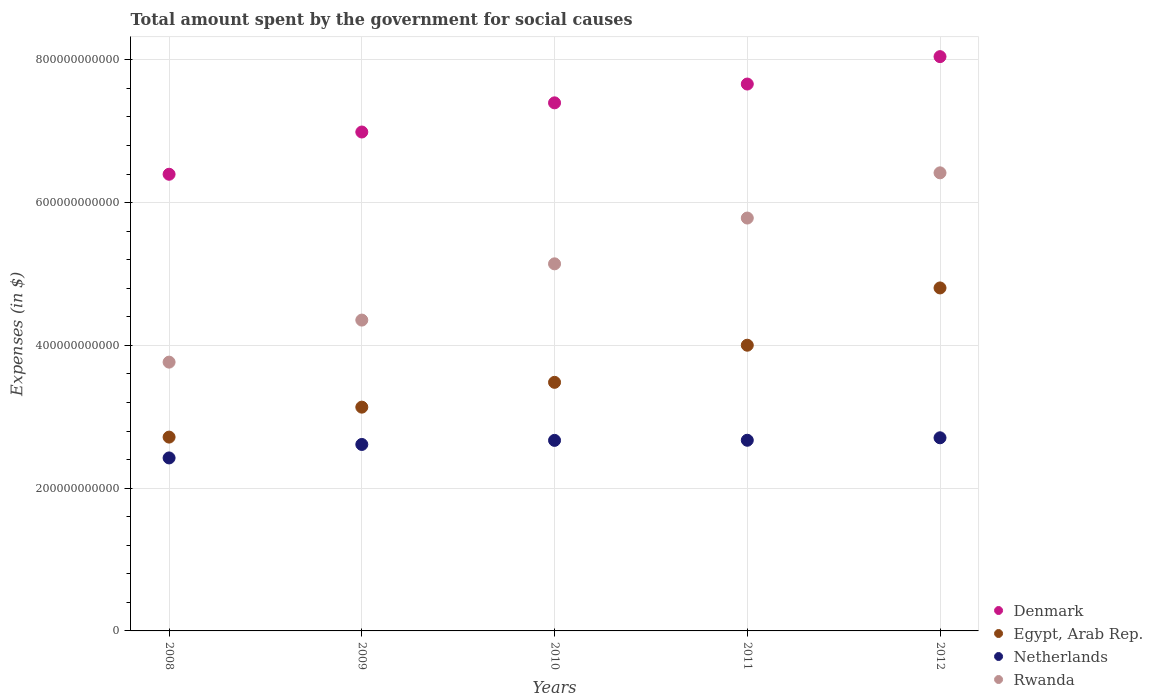Is the number of dotlines equal to the number of legend labels?
Keep it short and to the point. Yes. What is the amount spent for social causes by the government in Netherlands in 2011?
Make the answer very short. 2.67e+11. Across all years, what is the maximum amount spent for social causes by the government in Denmark?
Keep it short and to the point. 8.04e+11. Across all years, what is the minimum amount spent for social causes by the government in Egypt, Arab Rep.?
Provide a short and direct response. 2.71e+11. In which year was the amount spent for social causes by the government in Netherlands maximum?
Offer a terse response. 2012. In which year was the amount spent for social causes by the government in Egypt, Arab Rep. minimum?
Provide a succinct answer. 2008. What is the total amount spent for social causes by the government in Egypt, Arab Rep. in the graph?
Ensure brevity in your answer.  1.81e+12. What is the difference between the amount spent for social causes by the government in Netherlands in 2009 and that in 2011?
Give a very brief answer. -5.88e+09. What is the difference between the amount spent for social causes by the government in Egypt, Arab Rep. in 2008 and the amount spent for social causes by the government in Denmark in 2012?
Give a very brief answer. -5.33e+11. What is the average amount spent for social causes by the government in Egypt, Arab Rep. per year?
Ensure brevity in your answer.  3.63e+11. In the year 2011, what is the difference between the amount spent for social causes by the government in Egypt, Arab Rep. and amount spent for social causes by the government in Denmark?
Keep it short and to the point. -3.66e+11. In how many years, is the amount spent for social causes by the government in Egypt, Arab Rep. greater than 360000000000 $?
Your answer should be very brief. 2. What is the ratio of the amount spent for social causes by the government in Rwanda in 2008 to that in 2012?
Ensure brevity in your answer.  0.59. Is the amount spent for social causes by the government in Rwanda in 2008 less than that in 2010?
Give a very brief answer. Yes. What is the difference between the highest and the second highest amount spent for social causes by the government in Denmark?
Offer a terse response. 3.84e+1. What is the difference between the highest and the lowest amount spent for social causes by the government in Netherlands?
Ensure brevity in your answer.  2.82e+1. In how many years, is the amount spent for social causes by the government in Denmark greater than the average amount spent for social causes by the government in Denmark taken over all years?
Your answer should be compact. 3. Is the sum of the amount spent for social causes by the government in Denmark in 2011 and 2012 greater than the maximum amount spent for social causes by the government in Rwanda across all years?
Make the answer very short. Yes. Does the amount spent for social causes by the government in Netherlands monotonically increase over the years?
Give a very brief answer. Yes. Is the amount spent for social causes by the government in Rwanda strictly greater than the amount spent for social causes by the government in Egypt, Arab Rep. over the years?
Your response must be concise. Yes. How many dotlines are there?
Make the answer very short. 4. How many years are there in the graph?
Your answer should be compact. 5. What is the difference between two consecutive major ticks on the Y-axis?
Your answer should be compact. 2.00e+11. Does the graph contain any zero values?
Provide a succinct answer. No. Does the graph contain grids?
Offer a very short reply. Yes. What is the title of the graph?
Offer a terse response. Total amount spent by the government for social causes. Does "Madagascar" appear as one of the legend labels in the graph?
Give a very brief answer. No. What is the label or title of the Y-axis?
Make the answer very short. Expenses (in $). What is the Expenses (in $) of Denmark in 2008?
Keep it short and to the point. 6.40e+11. What is the Expenses (in $) of Egypt, Arab Rep. in 2008?
Provide a succinct answer. 2.71e+11. What is the Expenses (in $) of Netherlands in 2008?
Make the answer very short. 2.42e+11. What is the Expenses (in $) in Rwanda in 2008?
Your answer should be very brief. 3.77e+11. What is the Expenses (in $) in Denmark in 2009?
Your answer should be compact. 6.99e+11. What is the Expenses (in $) in Egypt, Arab Rep. in 2009?
Offer a terse response. 3.13e+11. What is the Expenses (in $) in Netherlands in 2009?
Keep it short and to the point. 2.61e+11. What is the Expenses (in $) in Rwanda in 2009?
Provide a short and direct response. 4.35e+11. What is the Expenses (in $) of Denmark in 2010?
Make the answer very short. 7.40e+11. What is the Expenses (in $) of Egypt, Arab Rep. in 2010?
Give a very brief answer. 3.48e+11. What is the Expenses (in $) in Netherlands in 2010?
Your response must be concise. 2.67e+11. What is the Expenses (in $) in Rwanda in 2010?
Your response must be concise. 5.14e+11. What is the Expenses (in $) in Denmark in 2011?
Offer a very short reply. 7.66e+11. What is the Expenses (in $) in Egypt, Arab Rep. in 2011?
Your answer should be very brief. 4.00e+11. What is the Expenses (in $) of Netherlands in 2011?
Offer a terse response. 2.67e+11. What is the Expenses (in $) of Rwanda in 2011?
Ensure brevity in your answer.  5.78e+11. What is the Expenses (in $) of Denmark in 2012?
Your answer should be compact. 8.04e+11. What is the Expenses (in $) in Egypt, Arab Rep. in 2012?
Offer a terse response. 4.80e+11. What is the Expenses (in $) of Netherlands in 2012?
Make the answer very short. 2.71e+11. What is the Expenses (in $) in Rwanda in 2012?
Keep it short and to the point. 6.42e+11. Across all years, what is the maximum Expenses (in $) of Denmark?
Your response must be concise. 8.04e+11. Across all years, what is the maximum Expenses (in $) of Egypt, Arab Rep.?
Offer a very short reply. 4.80e+11. Across all years, what is the maximum Expenses (in $) of Netherlands?
Your response must be concise. 2.71e+11. Across all years, what is the maximum Expenses (in $) in Rwanda?
Your response must be concise. 6.42e+11. Across all years, what is the minimum Expenses (in $) in Denmark?
Provide a succinct answer. 6.40e+11. Across all years, what is the minimum Expenses (in $) of Egypt, Arab Rep.?
Your answer should be very brief. 2.71e+11. Across all years, what is the minimum Expenses (in $) of Netherlands?
Your response must be concise. 2.42e+11. Across all years, what is the minimum Expenses (in $) of Rwanda?
Offer a very short reply. 3.77e+11. What is the total Expenses (in $) in Denmark in the graph?
Keep it short and to the point. 3.65e+12. What is the total Expenses (in $) in Egypt, Arab Rep. in the graph?
Your response must be concise. 1.81e+12. What is the total Expenses (in $) of Netherlands in the graph?
Offer a very short reply. 1.31e+12. What is the total Expenses (in $) of Rwanda in the graph?
Give a very brief answer. 2.55e+12. What is the difference between the Expenses (in $) of Denmark in 2008 and that in 2009?
Keep it short and to the point. -5.92e+1. What is the difference between the Expenses (in $) of Egypt, Arab Rep. in 2008 and that in 2009?
Give a very brief answer. -4.20e+1. What is the difference between the Expenses (in $) in Netherlands in 2008 and that in 2009?
Ensure brevity in your answer.  -1.89e+1. What is the difference between the Expenses (in $) in Rwanda in 2008 and that in 2009?
Offer a terse response. -5.89e+1. What is the difference between the Expenses (in $) of Denmark in 2008 and that in 2010?
Provide a succinct answer. -1.00e+11. What is the difference between the Expenses (in $) in Egypt, Arab Rep. in 2008 and that in 2010?
Provide a succinct answer. -7.67e+1. What is the difference between the Expenses (in $) of Netherlands in 2008 and that in 2010?
Offer a terse response. -2.46e+1. What is the difference between the Expenses (in $) of Rwanda in 2008 and that in 2010?
Provide a succinct answer. -1.38e+11. What is the difference between the Expenses (in $) in Denmark in 2008 and that in 2011?
Provide a succinct answer. -1.26e+11. What is the difference between the Expenses (in $) in Egypt, Arab Rep. in 2008 and that in 2011?
Provide a succinct answer. -1.29e+11. What is the difference between the Expenses (in $) in Netherlands in 2008 and that in 2011?
Provide a short and direct response. -2.48e+1. What is the difference between the Expenses (in $) of Rwanda in 2008 and that in 2011?
Your answer should be very brief. -2.02e+11. What is the difference between the Expenses (in $) in Denmark in 2008 and that in 2012?
Ensure brevity in your answer.  -1.65e+11. What is the difference between the Expenses (in $) of Egypt, Arab Rep. in 2008 and that in 2012?
Keep it short and to the point. -2.09e+11. What is the difference between the Expenses (in $) in Netherlands in 2008 and that in 2012?
Ensure brevity in your answer.  -2.82e+1. What is the difference between the Expenses (in $) of Rwanda in 2008 and that in 2012?
Offer a very short reply. -2.65e+11. What is the difference between the Expenses (in $) of Denmark in 2009 and that in 2010?
Offer a very short reply. -4.09e+1. What is the difference between the Expenses (in $) of Egypt, Arab Rep. in 2009 and that in 2010?
Offer a terse response. -3.48e+1. What is the difference between the Expenses (in $) of Netherlands in 2009 and that in 2010?
Make the answer very short. -5.71e+09. What is the difference between the Expenses (in $) of Rwanda in 2009 and that in 2010?
Your answer should be very brief. -7.88e+1. What is the difference between the Expenses (in $) of Denmark in 2009 and that in 2011?
Make the answer very short. -6.72e+1. What is the difference between the Expenses (in $) in Egypt, Arab Rep. in 2009 and that in 2011?
Your response must be concise. -8.68e+1. What is the difference between the Expenses (in $) in Netherlands in 2009 and that in 2011?
Offer a very short reply. -5.88e+09. What is the difference between the Expenses (in $) of Rwanda in 2009 and that in 2011?
Your answer should be compact. -1.43e+11. What is the difference between the Expenses (in $) in Denmark in 2009 and that in 2012?
Make the answer very short. -1.06e+11. What is the difference between the Expenses (in $) of Egypt, Arab Rep. in 2009 and that in 2012?
Offer a terse response. -1.67e+11. What is the difference between the Expenses (in $) in Netherlands in 2009 and that in 2012?
Offer a very short reply. -9.34e+09. What is the difference between the Expenses (in $) of Rwanda in 2009 and that in 2012?
Offer a terse response. -2.06e+11. What is the difference between the Expenses (in $) of Denmark in 2010 and that in 2011?
Offer a very short reply. -2.63e+1. What is the difference between the Expenses (in $) in Egypt, Arab Rep. in 2010 and that in 2011?
Offer a very short reply. -5.20e+1. What is the difference between the Expenses (in $) in Netherlands in 2010 and that in 2011?
Your answer should be very brief. -1.72e+08. What is the difference between the Expenses (in $) in Rwanda in 2010 and that in 2011?
Your answer should be compact. -6.41e+1. What is the difference between the Expenses (in $) of Denmark in 2010 and that in 2012?
Your answer should be very brief. -6.47e+1. What is the difference between the Expenses (in $) in Egypt, Arab Rep. in 2010 and that in 2012?
Give a very brief answer. -1.32e+11. What is the difference between the Expenses (in $) of Netherlands in 2010 and that in 2012?
Provide a succinct answer. -3.62e+09. What is the difference between the Expenses (in $) in Rwanda in 2010 and that in 2012?
Offer a very short reply. -1.27e+11. What is the difference between the Expenses (in $) in Denmark in 2011 and that in 2012?
Make the answer very short. -3.84e+1. What is the difference between the Expenses (in $) in Egypt, Arab Rep. in 2011 and that in 2012?
Offer a terse response. -8.02e+1. What is the difference between the Expenses (in $) in Netherlands in 2011 and that in 2012?
Provide a short and direct response. -3.45e+09. What is the difference between the Expenses (in $) in Rwanda in 2011 and that in 2012?
Your response must be concise. -6.33e+1. What is the difference between the Expenses (in $) in Denmark in 2008 and the Expenses (in $) in Egypt, Arab Rep. in 2009?
Offer a very short reply. 3.26e+11. What is the difference between the Expenses (in $) of Denmark in 2008 and the Expenses (in $) of Netherlands in 2009?
Offer a terse response. 3.78e+11. What is the difference between the Expenses (in $) in Denmark in 2008 and the Expenses (in $) in Rwanda in 2009?
Your answer should be compact. 2.04e+11. What is the difference between the Expenses (in $) of Egypt, Arab Rep. in 2008 and the Expenses (in $) of Netherlands in 2009?
Make the answer very short. 1.03e+1. What is the difference between the Expenses (in $) of Egypt, Arab Rep. in 2008 and the Expenses (in $) of Rwanda in 2009?
Keep it short and to the point. -1.64e+11. What is the difference between the Expenses (in $) in Netherlands in 2008 and the Expenses (in $) in Rwanda in 2009?
Your answer should be compact. -1.93e+11. What is the difference between the Expenses (in $) in Denmark in 2008 and the Expenses (in $) in Egypt, Arab Rep. in 2010?
Offer a terse response. 2.91e+11. What is the difference between the Expenses (in $) of Denmark in 2008 and the Expenses (in $) of Netherlands in 2010?
Offer a very short reply. 3.73e+11. What is the difference between the Expenses (in $) in Denmark in 2008 and the Expenses (in $) in Rwanda in 2010?
Keep it short and to the point. 1.25e+11. What is the difference between the Expenses (in $) in Egypt, Arab Rep. in 2008 and the Expenses (in $) in Netherlands in 2010?
Make the answer very short. 4.58e+09. What is the difference between the Expenses (in $) of Egypt, Arab Rep. in 2008 and the Expenses (in $) of Rwanda in 2010?
Provide a succinct answer. -2.43e+11. What is the difference between the Expenses (in $) in Netherlands in 2008 and the Expenses (in $) in Rwanda in 2010?
Give a very brief answer. -2.72e+11. What is the difference between the Expenses (in $) of Denmark in 2008 and the Expenses (in $) of Egypt, Arab Rep. in 2011?
Give a very brief answer. 2.39e+11. What is the difference between the Expenses (in $) in Denmark in 2008 and the Expenses (in $) in Netherlands in 2011?
Offer a very short reply. 3.73e+11. What is the difference between the Expenses (in $) of Denmark in 2008 and the Expenses (in $) of Rwanda in 2011?
Your response must be concise. 6.13e+1. What is the difference between the Expenses (in $) of Egypt, Arab Rep. in 2008 and the Expenses (in $) of Netherlands in 2011?
Give a very brief answer. 4.41e+09. What is the difference between the Expenses (in $) of Egypt, Arab Rep. in 2008 and the Expenses (in $) of Rwanda in 2011?
Give a very brief answer. -3.07e+11. What is the difference between the Expenses (in $) in Netherlands in 2008 and the Expenses (in $) in Rwanda in 2011?
Give a very brief answer. -3.36e+11. What is the difference between the Expenses (in $) in Denmark in 2008 and the Expenses (in $) in Egypt, Arab Rep. in 2012?
Provide a short and direct response. 1.59e+11. What is the difference between the Expenses (in $) in Denmark in 2008 and the Expenses (in $) in Netherlands in 2012?
Your response must be concise. 3.69e+11. What is the difference between the Expenses (in $) in Denmark in 2008 and the Expenses (in $) in Rwanda in 2012?
Your answer should be compact. -2.00e+09. What is the difference between the Expenses (in $) in Egypt, Arab Rep. in 2008 and the Expenses (in $) in Netherlands in 2012?
Ensure brevity in your answer.  9.57e+08. What is the difference between the Expenses (in $) in Egypt, Arab Rep. in 2008 and the Expenses (in $) in Rwanda in 2012?
Your answer should be very brief. -3.70e+11. What is the difference between the Expenses (in $) of Netherlands in 2008 and the Expenses (in $) of Rwanda in 2012?
Give a very brief answer. -3.99e+11. What is the difference between the Expenses (in $) in Denmark in 2009 and the Expenses (in $) in Egypt, Arab Rep. in 2010?
Give a very brief answer. 3.51e+11. What is the difference between the Expenses (in $) in Denmark in 2009 and the Expenses (in $) in Netherlands in 2010?
Offer a terse response. 4.32e+11. What is the difference between the Expenses (in $) of Denmark in 2009 and the Expenses (in $) of Rwanda in 2010?
Give a very brief answer. 1.85e+11. What is the difference between the Expenses (in $) in Egypt, Arab Rep. in 2009 and the Expenses (in $) in Netherlands in 2010?
Offer a terse response. 4.65e+1. What is the difference between the Expenses (in $) in Egypt, Arab Rep. in 2009 and the Expenses (in $) in Rwanda in 2010?
Give a very brief answer. -2.01e+11. What is the difference between the Expenses (in $) of Netherlands in 2009 and the Expenses (in $) of Rwanda in 2010?
Provide a succinct answer. -2.53e+11. What is the difference between the Expenses (in $) in Denmark in 2009 and the Expenses (in $) in Egypt, Arab Rep. in 2011?
Your response must be concise. 2.99e+11. What is the difference between the Expenses (in $) in Denmark in 2009 and the Expenses (in $) in Netherlands in 2011?
Provide a short and direct response. 4.32e+11. What is the difference between the Expenses (in $) in Denmark in 2009 and the Expenses (in $) in Rwanda in 2011?
Provide a short and direct response. 1.21e+11. What is the difference between the Expenses (in $) in Egypt, Arab Rep. in 2009 and the Expenses (in $) in Netherlands in 2011?
Give a very brief answer. 4.64e+1. What is the difference between the Expenses (in $) in Egypt, Arab Rep. in 2009 and the Expenses (in $) in Rwanda in 2011?
Your response must be concise. -2.65e+11. What is the difference between the Expenses (in $) in Netherlands in 2009 and the Expenses (in $) in Rwanda in 2011?
Offer a very short reply. -3.17e+11. What is the difference between the Expenses (in $) of Denmark in 2009 and the Expenses (in $) of Egypt, Arab Rep. in 2012?
Offer a terse response. 2.18e+11. What is the difference between the Expenses (in $) in Denmark in 2009 and the Expenses (in $) in Netherlands in 2012?
Keep it short and to the point. 4.28e+11. What is the difference between the Expenses (in $) in Denmark in 2009 and the Expenses (in $) in Rwanda in 2012?
Ensure brevity in your answer.  5.72e+1. What is the difference between the Expenses (in $) of Egypt, Arab Rep. in 2009 and the Expenses (in $) of Netherlands in 2012?
Your answer should be very brief. 4.29e+1. What is the difference between the Expenses (in $) in Egypt, Arab Rep. in 2009 and the Expenses (in $) in Rwanda in 2012?
Offer a terse response. -3.28e+11. What is the difference between the Expenses (in $) of Netherlands in 2009 and the Expenses (in $) of Rwanda in 2012?
Provide a short and direct response. -3.80e+11. What is the difference between the Expenses (in $) in Denmark in 2010 and the Expenses (in $) in Egypt, Arab Rep. in 2011?
Give a very brief answer. 3.40e+11. What is the difference between the Expenses (in $) in Denmark in 2010 and the Expenses (in $) in Netherlands in 2011?
Provide a short and direct response. 4.73e+11. What is the difference between the Expenses (in $) in Denmark in 2010 and the Expenses (in $) in Rwanda in 2011?
Offer a terse response. 1.61e+11. What is the difference between the Expenses (in $) of Egypt, Arab Rep. in 2010 and the Expenses (in $) of Netherlands in 2011?
Your answer should be compact. 8.11e+1. What is the difference between the Expenses (in $) of Egypt, Arab Rep. in 2010 and the Expenses (in $) of Rwanda in 2011?
Offer a terse response. -2.30e+11. What is the difference between the Expenses (in $) in Netherlands in 2010 and the Expenses (in $) in Rwanda in 2011?
Your response must be concise. -3.11e+11. What is the difference between the Expenses (in $) of Denmark in 2010 and the Expenses (in $) of Egypt, Arab Rep. in 2012?
Provide a short and direct response. 2.59e+11. What is the difference between the Expenses (in $) in Denmark in 2010 and the Expenses (in $) in Netherlands in 2012?
Give a very brief answer. 4.69e+11. What is the difference between the Expenses (in $) in Denmark in 2010 and the Expenses (in $) in Rwanda in 2012?
Your answer should be very brief. 9.80e+1. What is the difference between the Expenses (in $) of Egypt, Arab Rep. in 2010 and the Expenses (in $) of Netherlands in 2012?
Offer a very short reply. 7.77e+1. What is the difference between the Expenses (in $) in Egypt, Arab Rep. in 2010 and the Expenses (in $) in Rwanda in 2012?
Your answer should be compact. -2.93e+11. What is the difference between the Expenses (in $) of Netherlands in 2010 and the Expenses (in $) of Rwanda in 2012?
Your answer should be very brief. -3.75e+11. What is the difference between the Expenses (in $) in Denmark in 2011 and the Expenses (in $) in Egypt, Arab Rep. in 2012?
Your response must be concise. 2.86e+11. What is the difference between the Expenses (in $) in Denmark in 2011 and the Expenses (in $) in Netherlands in 2012?
Make the answer very short. 4.96e+11. What is the difference between the Expenses (in $) of Denmark in 2011 and the Expenses (in $) of Rwanda in 2012?
Offer a very short reply. 1.24e+11. What is the difference between the Expenses (in $) in Egypt, Arab Rep. in 2011 and the Expenses (in $) in Netherlands in 2012?
Offer a terse response. 1.30e+11. What is the difference between the Expenses (in $) in Egypt, Arab Rep. in 2011 and the Expenses (in $) in Rwanda in 2012?
Your answer should be compact. -2.41e+11. What is the difference between the Expenses (in $) in Netherlands in 2011 and the Expenses (in $) in Rwanda in 2012?
Ensure brevity in your answer.  -3.75e+11. What is the average Expenses (in $) in Denmark per year?
Offer a very short reply. 7.30e+11. What is the average Expenses (in $) of Egypt, Arab Rep. per year?
Give a very brief answer. 3.63e+11. What is the average Expenses (in $) of Netherlands per year?
Your answer should be compact. 2.62e+11. What is the average Expenses (in $) of Rwanda per year?
Your answer should be very brief. 5.09e+11. In the year 2008, what is the difference between the Expenses (in $) in Denmark and Expenses (in $) in Egypt, Arab Rep.?
Ensure brevity in your answer.  3.68e+11. In the year 2008, what is the difference between the Expenses (in $) of Denmark and Expenses (in $) of Netherlands?
Offer a very short reply. 3.97e+11. In the year 2008, what is the difference between the Expenses (in $) in Denmark and Expenses (in $) in Rwanda?
Provide a succinct answer. 2.63e+11. In the year 2008, what is the difference between the Expenses (in $) in Egypt, Arab Rep. and Expenses (in $) in Netherlands?
Give a very brief answer. 2.92e+1. In the year 2008, what is the difference between the Expenses (in $) in Egypt, Arab Rep. and Expenses (in $) in Rwanda?
Your answer should be compact. -1.05e+11. In the year 2008, what is the difference between the Expenses (in $) in Netherlands and Expenses (in $) in Rwanda?
Your answer should be compact. -1.34e+11. In the year 2009, what is the difference between the Expenses (in $) in Denmark and Expenses (in $) in Egypt, Arab Rep.?
Provide a short and direct response. 3.85e+11. In the year 2009, what is the difference between the Expenses (in $) of Denmark and Expenses (in $) of Netherlands?
Offer a very short reply. 4.38e+11. In the year 2009, what is the difference between the Expenses (in $) of Denmark and Expenses (in $) of Rwanda?
Give a very brief answer. 2.63e+11. In the year 2009, what is the difference between the Expenses (in $) in Egypt, Arab Rep. and Expenses (in $) in Netherlands?
Provide a succinct answer. 5.23e+1. In the year 2009, what is the difference between the Expenses (in $) of Egypt, Arab Rep. and Expenses (in $) of Rwanda?
Provide a short and direct response. -1.22e+11. In the year 2009, what is the difference between the Expenses (in $) of Netherlands and Expenses (in $) of Rwanda?
Ensure brevity in your answer.  -1.74e+11. In the year 2010, what is the difference between the Expenses (in $) in Denmark and Expenses (in $) in Egypt, Arab Rep.?
Your answer should be compact. 3.92e+11. In the year 2010, what is the difference between the Expenses (in $) in Denmark and Expenses (in $) in Netherlands?
Give a very brief answer. 4.73e+11. In the year 2010, what is the difference between the Expenses (in $) in Denmark and Expenses (in $) in Rwanda?
Provide a succinct answer. 2.26e+11. In the year 2010, what is the difference between the Expenses (in $) in Egypt, Arab Rep. and Expenses (in $) in Netherlands?
Offer a very short reply. 8.13e+1. In the year 2010, what is the difference between the Expenses (in $) of Egypt, Arab Rep. and Expenses (in $) of Rwanda?
Provide a short and direct response. -1.66e+11. In the year 2010, what is the difference between the Expenses (in $) in Netherlands and Expenses (in $) in Rwanda?
Make the answer very short. -2.47e+11. In the year 2011, what is the difference between the Expenses (in $) in Denmark and Expenses (in $) in Egypt, Arab Rep.?
Ensure brevity in your answer.  3.66e+11. In the year 2011, what is the difference between the Expenses (in $) of Denmark and Expenses (in $) of Netherlands?
Give a very brief answer. 4.99e+11. In the year 2011, what is the difference between the Expenses (in $) in Denmark and Expenses (in $) in Rwanda?
Your answer should be very brief. 1.88e+11. In the year 2011, what is the difference between the Expenses (in $) in Egypt, Arab Rep. and Expenses (in $) in Netherlands?
Keep it short and to the point. 1.33e+11. In the year 2011, what is the difference between the Expenses (in $) of Egypt, Arab Rep. and Expenses (in $) of Rwanda?
Provide a succinct answer. -1.78e+11. In the year 2011, what is the difference between the Expenses (in $) in Netherlands and Expenses (in $) in Rwanda?
Make the answer very short. -3.11e+11. In the year 2012, what is the difference between the Expenses (in $) of Denmark and Expenses (in $) of Egypt, Arab Rep.?
Provide a short and direct response. 3.24e+11. In the year 2012, what is the difference between the Expenses (in $) of Denmark and Expenses (in $) of Netherlands?
Ensure brevity in your answer.  5.34e+11. In the year 2012, what is the difference between the Expenses (in $) of Denmark and Expenses (in $) of Rwanda?
Provide a short and direct response. 1.63e+11. In the year 2012, what is the difference between the Expenses (in $) of Egypt, Arab Rep. and Expenses (in $) of Netherlands?
Provide a succinct answer. 2.10e+11. In the year 2012, what is the difference between the Expenses (in $) of Egypt, Arab Rep. and Expenses (in $) of Rwanda?
Ensure brevity in your answer.  -1.61e+11. In the year 2012, what is the difference between the Expenses (in $) in Netherlands and Expenses (in $) in Rwanda?
Your answer should be very brief. -3.71e+11. What is the ratio of the Expenses (in $) of Denmark in 2008 to that in 2009?
Your answer should be compact. 0.92. What is the ratio of the Expenses (in $) of Egypt, Arab Rep. in 2008 to that in 2009?
Your answer should be very brief. 0.87. What is the ratio of the Expenses (in $) in Netherlands in 2008 to that in 2009?
Provide a succinct answer. 0.93. What is the ratio of the Expenses (in $) in Rwanda in 2008 to that in 2009?
Provide a short and direct response. 0.86. What is the ratio of the Expenses (in $) in Denmark in 2008 to that in 2010?
Your answer should be compact. 0.86. What is the ratio of the Expenses (in $) of Egypt, Arab Rep. in 2008 to that in 2010?
Provide a short and direct response. 0.78. What is the ratio of the Expenses (in $) of Netherlands in 2008 to that in 2010?
Keep it short and to the point. 0.91. What is the ratio of the Expenses (in $) in Rwanda in 2008 to that in 2010?
Your response must be concise. 0.73. What is the ratio of the Expenses (in $) of Denmark in 2008 to that in 2011?
Give a very brief answer. 0.83. What is the ratio of the Expenses (in $) in Egypt, Arab Rep. in 2008 to that in 2011?
Give a very brief answer. 0.68. What is the ratio of the Expenses (in $) of Netherlands in 2008 to that in 2011?
Provide a short and direct response. 0.91. What is the ratio of the Expenses (in $) of Rwanda in 2008 to that in 2011?
Ensure brevity in your answer.  0.65. What is the ratio of the Expenses (in $) of Denmark in 2008 to that in 2012?
Provide a succinct answer. 0.8. What is the ratio of the Expenses (in $) of Egypt, Arab Rep. in 2008 to that in 2012?
Ensure brevity in your answer.  0.57. What is the ratio of the Expenses (in $) of Netherlands in 2008 to that in 2012?
Your answer should be compact. 0.9. What is the ratio of the Expenses (in $) of Rwanda in 2008 to that in 2012?
Keep it short and to the point. 0.59. What is the ratio of the Expenses (in $) in Denmark in 2009 to that in 2010?
Your answer should be compact. 0.94. What is the ratio of the Expenses (in $) in Egypt, Arab Rep. in 2009 to that in 2010?
Offer a very short reply. 0.9. What is the ratio of the Expenses (in $) in Netherlands in 2009 to that in 2010?
Your answer should be compact. 0.98. What is the ratio of the Expenses (in $) in Rwanda in 2009 to that in 2010?
Your answer should be compact. 0.85. What is the ratio of the Expenses (in $) in Denmark in 2009 to that in 2011?
Give a very brief answer. 0.91. What is the ratio of the Expenses (in $) of Egypt, Arab Rep. in 2009 to that in 2011?
Offer a very short reply. 0.78. What is the ratio of the Expenses (in $) in Rwanda in 2009 to that in 2011?
Your response must be concise. 0.75. What is the ratio of the Expenses (in $) of Denmark in 2009 to that in 2012?
Offer a terse response. 0.87. What is the ratio of the Expenses (in $) of Egypt, Arab Rep. in 2009 to that in 2012?
Make the answer very short. 0.65. What is the ratio of the Expenses (in $) in Netherlands in 2009 to that in 2012?
Ensure brevity in your answer.  0.97. What is the ratio of the Expenses (in $) in Rwanda in 2009 to that in 2012?
Your response must be concise. 0.68. What is the ratio of the Expenses (in $) of Denmark in 2010 to that in 2011?
Keep it short and to the point. 0.97. What is the ratio of the Expenses (in $) in Egypt, Arab Rep. in 2010 to that in 2011?
Your answer should be compact. 0.87. What is the ratio of the Expenses (in $) of Netherlands in 2010 to that in 2011?
Make the answer very short. 1. What is the ratio of the Expenses (in $) of Rwanda in 2010 to that in 2011?
Offer a terse response. 0.89. What is the ratio of the Expenses (in $) of Denmark in 2010 to that in 2012?
Give a very brief answer. 0.92. What is the ratio of the Expenses (in $) in Egypt, Arab Rep. in 2010 to that in 2012?
Provide a short and direct response. 0.72. What is the ratio of the Expenses (in $) in Netherlands in 2010 to that in 2012?
Give a very brief answer. 0.99. What is the ratio of the Expenses (in $) of Rwanda in 2010 to that in 2012?
Give a very brief answer. 0.8. What is the ratio of the Expenses (in $) of Denmark in 2011 to that in 2012?
Ensure brevity in your answer.  0.95. What is the ratio of the Expenses (in $) of Egypt, Arab Rep. in 2011 to that in 2012?
Make the answer very short. 0.83. What is the ratio of the Expenses (in $) of Netherlands in 2011 to that in 2012?
Give a very brief answer. 0.99. What is the ratio of the Expenses (in $) of Rwanda in 2011 to that in 2012?
Offer a very short reply. 0.9. What is the difference between the highest and the second highest Expenses (in $) in Denmark?
Give a very brief answer. 3.84e+1. What is the difference between the highest and the second highest Expenses (in $) of Egypt, Arab Rep.?
Give a very brief answer. 8.02e+1. What is the difference between the highest and the second highest Expenses (in $) in Netherlands?
Give a very brief answer. 3.45e+09. What is the difference between the highest and the second highest Expenses (in $) in Rwanda?
Your answer should be compact. 6.33e+1. What is the difference between the highest and the lowest Expenses (in $) in Denmark?
Provide a short and direct response. 1.65e+11. What is the difference between the highest and the lowest Expenses (in $) in Egypt, Arab Rep.?
Your response must be concise. 2.09e+11. What is the difference between the highest and the lowest Expenses (in $) in Netherlands?
Keep it short and to the point. 2.82e+1. What is the difference between the highest and the lowest Expenses (in $) of Rwanda?
Offer a terse response. 2.65e+11. 